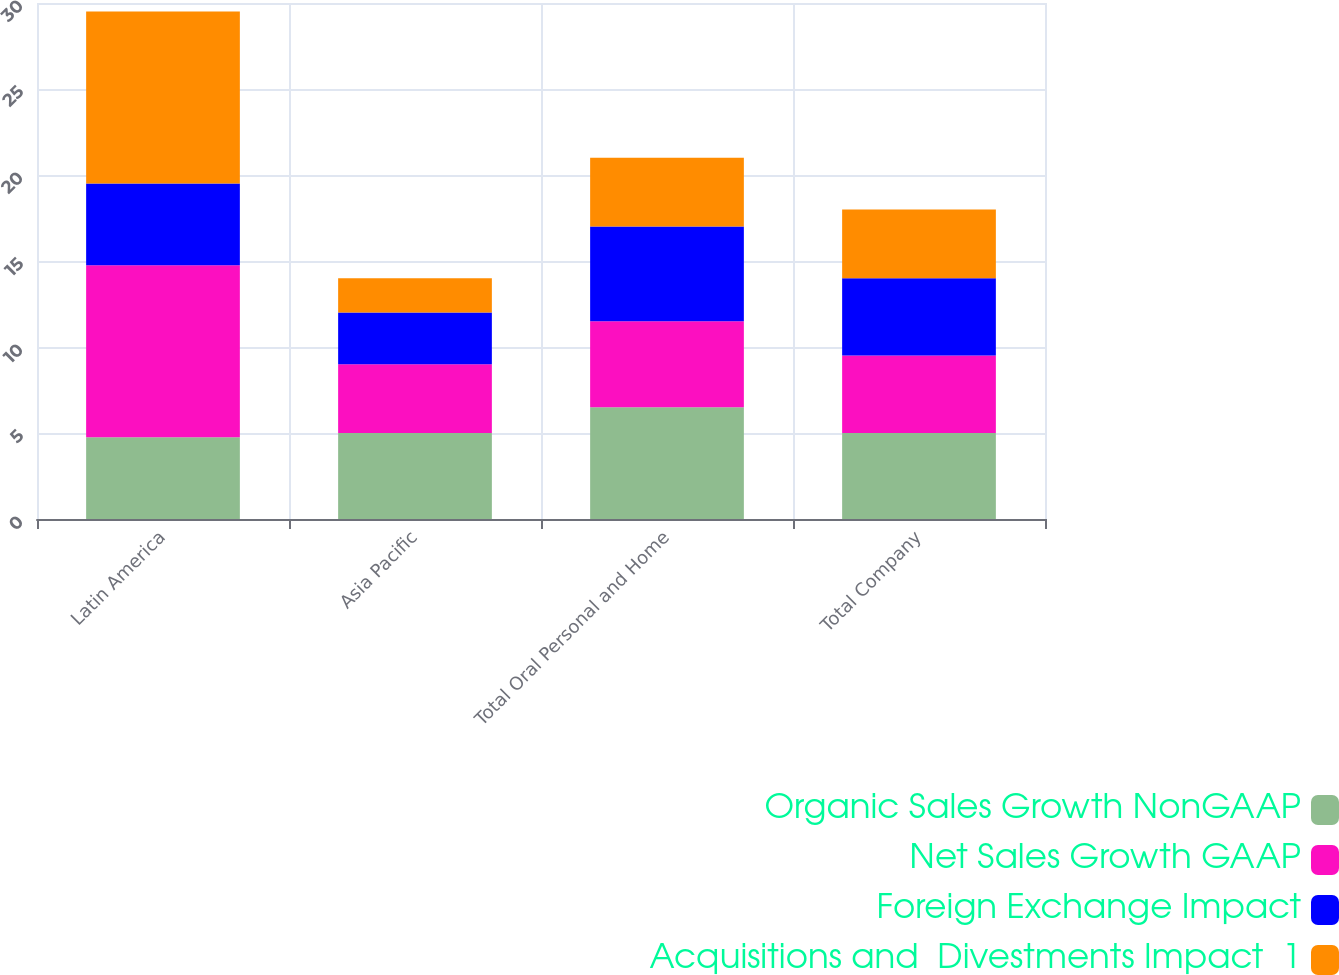Convert chart to OTSL. <chart><loc_0><loc_0><loc_500><loc_500><stacked_bar_chart><ecel><fcel>Latin America<fcel>Asia Pacific<fcel>Total Oral Personal and Home<fcel>Total Company<nl><fcel>Organic Sales Growth NonGAAP<fcel>4.75<fcel>5<fcel>6.5<fcel>5<nl><fcel>Net Sales Growth GAAP<fcel>10<fcel>4<fcel>5<fcel>4.5<nl><fcel>Foreign Exchange Impact<fcel>4.75<fcel>3<fcel>5.5<fcel>4.5<nl><fcel>Acquisitions and  Divestments Impact  1<fcel>10<fcel>2<fcel>4<fcel>4<nl></chart> 